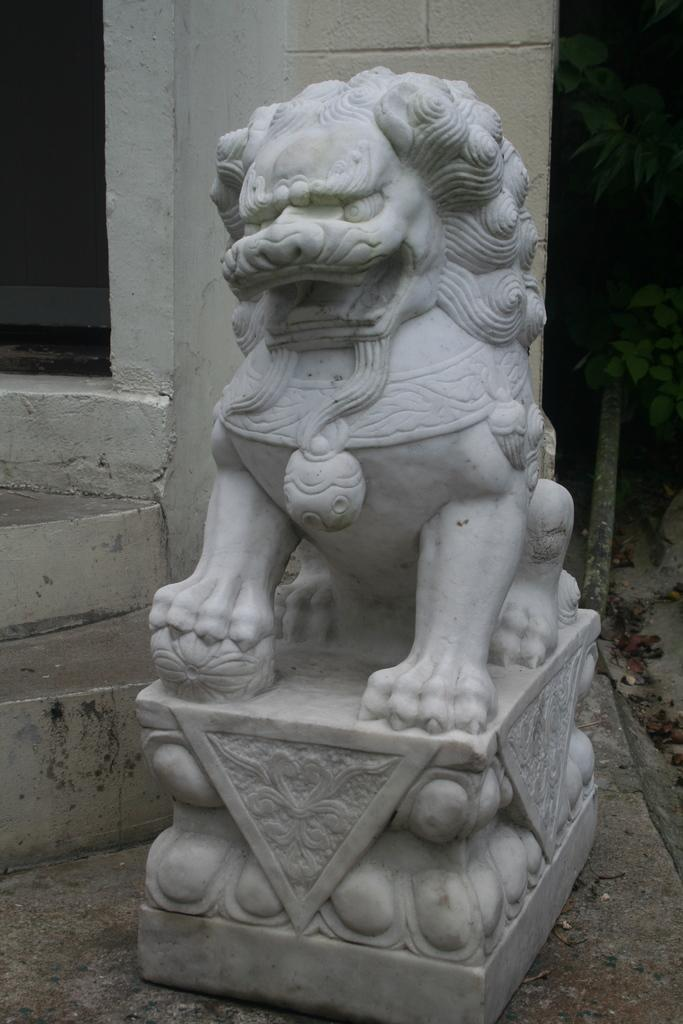What is the main subject in the image? There is a sculpture in the image. Where is the sculpture located in relation to the image? The sculpture is in the front of the image. What can be seen on the right side of the image? There is a plant on the right side of the image. What is visible in the background of the image? There is a wall in the background of the image. How does the mother interact with the sculpture in the image? There is no mother present in the image, so there is no interaction to describe. 